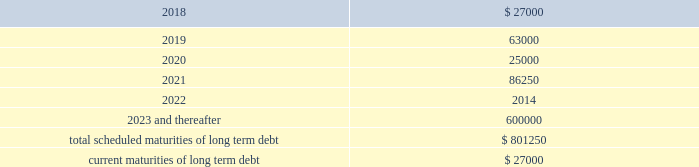Other long term debt in december 2012 , the company entered into a $ 50.0 million recourse loan collateralized by the land , buildings and tenant improvements comprising the company 2019s corporate headquarters .
The loan has a seven year term and maturity date of december 2019 .
The loan bears interest at one month libor plus a margin of 1.50% ( 1.50 % ) , and allows for prepayment without penalty .
The loan includes covenants and events of default substantially consistent with the company 2019s credit agreement discussed above .
The loan also requires prior approval of the lender for certain matters related to the property , including transfers of any interest in the property .
As of december 31 , 2017 and 2016 , the outstanding balance on the loan was $ 40.0 million and $ 42.0 million , respectively .
The weighted average interest rate on the loan was 2.5% ( 2.5 % ) and 2.0% ( 2.0 % ) for the years ended december 31 , 2017 and 2016 , respectively .
The following are the scheduled maturities of long term debt as of december 31 , 2017 : ( in thousands ) .
Interest expense , net was $ 34.5 million , $ 26.4 million , and $ 14.6 million for the years ended december 31 , 2017 , 2016 and 2015 , respectively .
Interest expense includes the amortization of deferred financing costs , bank fees , capital and built-to-suit lease interest and interest expense under the credit and other long term debt facilities .
Amortization of deferred financing costs was $ 1.3 million , $ 1.2 million , and $ 0.8 million for the years ended december 31 , 2017 , 2016 and 2015 , respectively .
The company monitors the financial health and stability of its lenders under the credit and other long term debt facilities , however during any period of significant instability in the credit markets lenders could be negatively impacted in their ability to perform under these facilities .
Commitments and contingencies obligations under operating leases the company leases warehouse space , office facilities , space for its brand and factory house stores and certain equipment under non-cancelable operating leases .
The leases expire at various dates through 2033 , excluding extensions at the company 2019s option , and include provisions for rental adjustments .
The table below includes executed lease agreements for brand and factory house stores that the company did not yet occupy as of december 31 , 2017 and does not include contingent rent the company may incur at its stores based on future sales above a specified minimum or payments made for maintenance , insurance and real estate taxes .
The following is a schedule of future minimum lease payments for non-cancelable real property operating leases as of december 31 , 2017 as well as .
What was the percentage change in interest expense net from 2016 to 2017? 
Computations: ((34.5 - 26.4) / 26.4)
Answer: 0.30682. 